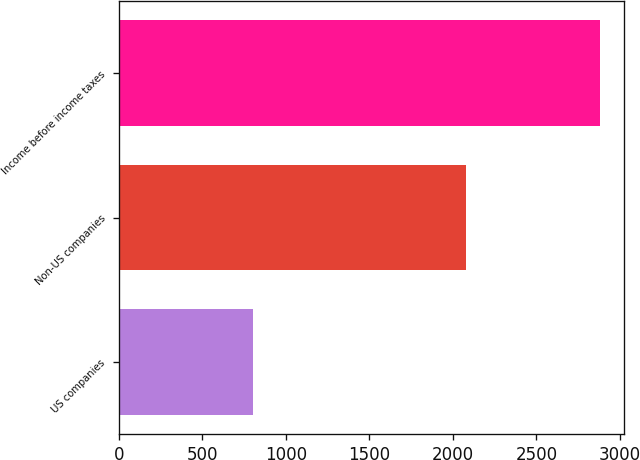<chart> <loc_0><loc_0><loc_500><loc_500><bar_chart><fcel>US companies<fcel>Non-US companies<fcel>Income before income taxes<nl><fcel>801<fcel>2081<fcel>2882<nl></chart> 